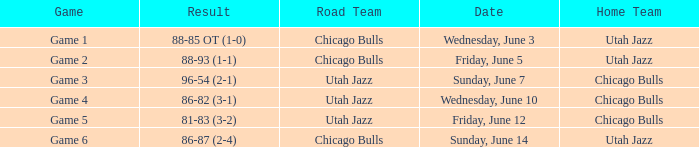Result of 86-87 (2-4) is what game? Game 6. 